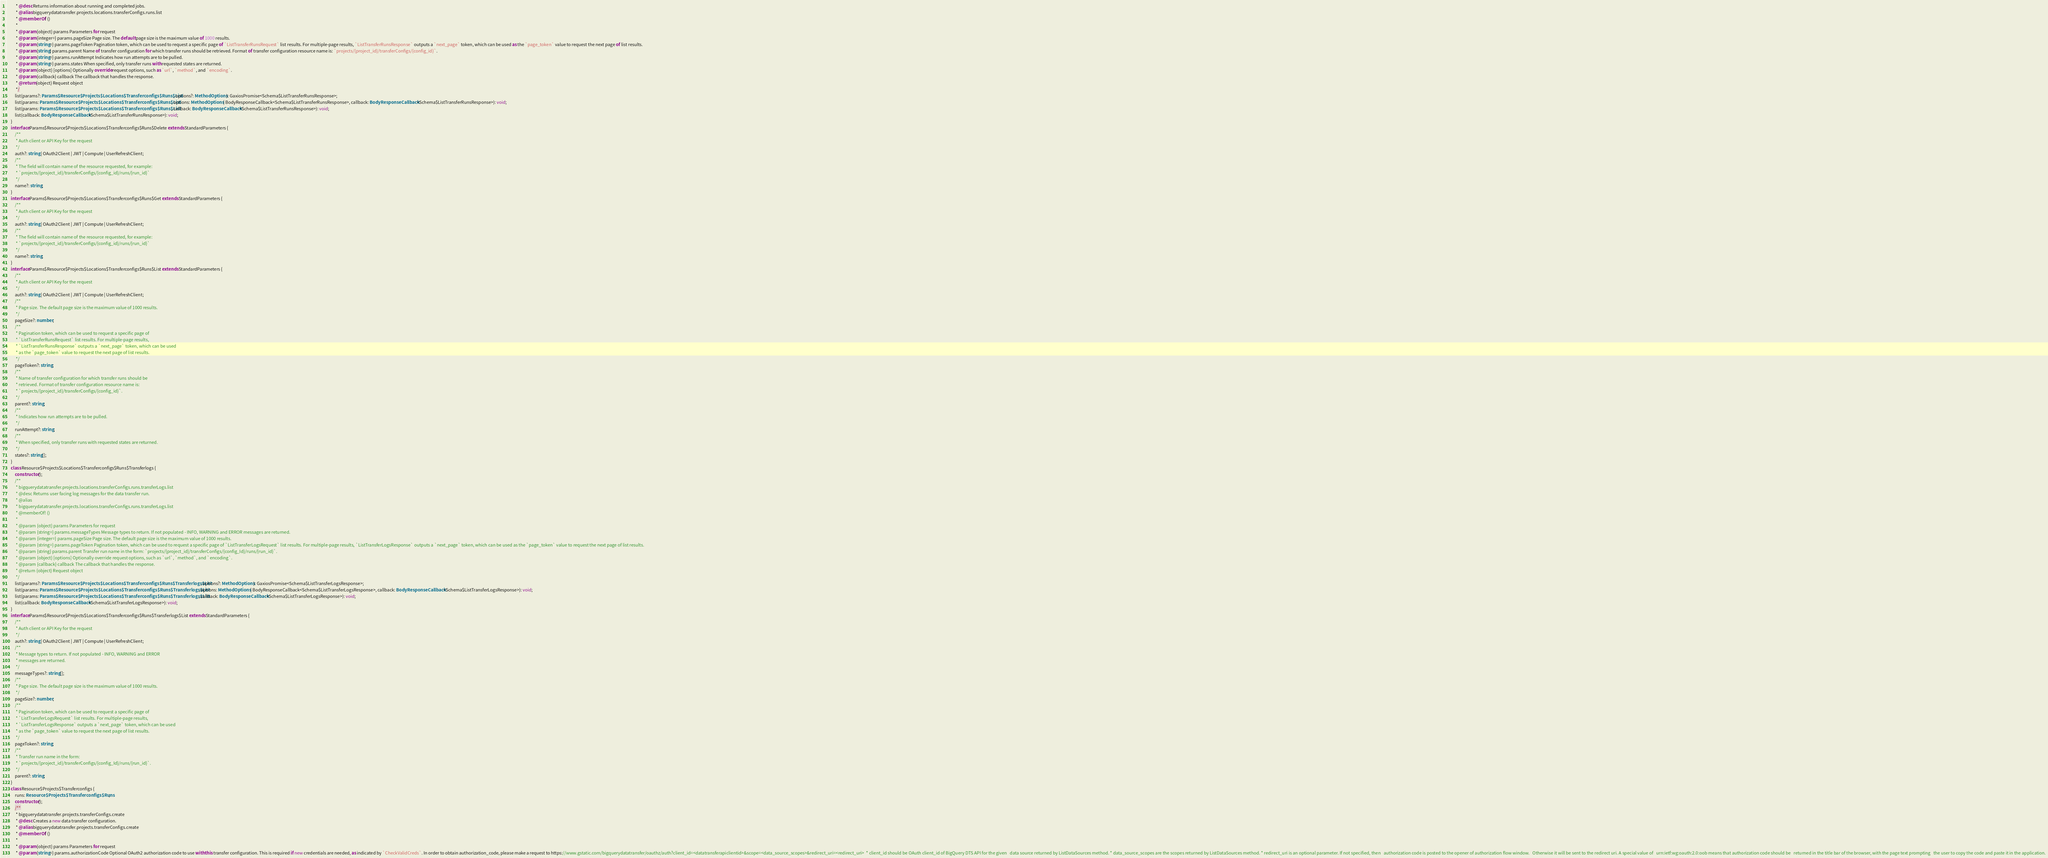Convert code to text. <code><loc_0><loc_0><loc_500><loc_500><_TypeScript_>         * @desc Returns information about running and completed jobs.
         * @alias bigquerydatatransfer.projects.locations.transferConfigs.runs.list
         * @memberOf! ()
         *
         * @param {object} params Parameters for request
         * @param {integer=} params.pageSize Page size. The default page size is the maximum value of 1000 results.
         * @param {string=} params.pageToken Pagination token, which can be used to request a specific page of `ListTransferRunsRequest` list results. For multiple-page results, `ListTransferRunsResponse` outputs a `next_page` token, which can be used as the `page_token` value to request the next page of list results.
         * @param {string} params.parent Name of transfer configuration for which transfer runs should be retrieved. Format of transfer configuration resource name is: `projects/{project_id}/transferConfigs/{config_id}`.
         * @param {string=} params.runAttempt Indicates how run attempts are to be pulled.
         * @param {string=} params.states When specified, only transfer runs with requested states are returned.
         * @param {object} [options] Optionally override request options, such as `url`, `method`, and `encoding`.
         * @param {callback} callback The callback that handles the response.
         * @return {object} Request object
         */
        list(params?: Params$Resource$Projects$Locations$Transferconfigs$Runs$List, options?: MethodOptions): GaxiosPromise<Schema$ListTransferRunsResponse>;
        list(params: Params$Resource$Projects$Locations$Transferconfigs$Runs$List, options: MethodOptions | BodyResponseCallback<Schema$ListTransferRunsResponse>, callback: BodyResponseCallback<Schema$ListTransferRunsResponse>): void;
        list(params: Params$Resource$Projects$Locations$Transferconfigs$Runs$List, callback: BodyResponseCallback<Schema$ListTransferRunsResponse>): void;
        list(callback: BodyResponseCallback<Schema$ListTransferRunsResponse>): void;
    }
    interface Params$Resource$Projects$Locations$Transferconfigs$Runs$Delete extends StandardParameters {
        /**
         * Auth client or API Key for the request
         */
        auth?: string | OAuth2Client | JWT | Compute | UserRefreshClient;
        /**
         * The field will contain name of the resource requested, for example:
         * `projects/{project_id}/transferConfigs/{config_id}/runs/{run_id}`
         */
        name?: string;
    }
    interface Params$Resource$Projects$Locations$Transferconfigs$Runs$Get extends StandardParameters {
        /**
         * Auth client or API Key for the request
         */
        auth?: string | OAuth2Client | JWT | Compute | UserRefreshClient;
        /**
         * The field will contain name of the resource requested, for example:
         * `projects/{project_id}/transferConfigs/{config_id}/runs/{run_id}`
         */
        name?: string;
    }
    interface Params$Resource$Projects$Locations$Transferconfigs$Runs$List extends StandardParameters {
        /**
         * Auth client or API Key for the request
         */
        auth?: string | OAuth2Client | JWT | Compute | UserRefreshClient;
        /**
         * Page size. The default page size is the maximum value of 1000 results.
         */
        pageSize?: number;
        /**
         * Pagination token, which can be used to request a specific page of
         * `ListTransferRunsRequest` list results. For multiple-page results,
         * `ListTransferRunsResponse` outputs a `next_page` token, which can be used
         * as the `page_token` value to request the next page of list results.
         */
        pageToken?: string;
        /**
         * Name of transfer configuration for which transfer runs should be
         * retrieved. Format of transfer configuration resource name is:
         * `projects/{project_id}/transferConfigs/{config_id}`.
         */
        parent?: string;
        /**
         * Indicates how run attempts are to be pulled.
         */
        runAttempt?: string;
        /**
         * When specified, only transfer runs with requested states are returned.
         */
        states?: string[];
    }
    class Resource$Projects$Locations$Transferconfigs$Runs$Transferlogs {
        constructor();
        /**
         * bigquerydatatransfer.projects.locations.transferConfigs.runs.transferLogs.list
         * @desc Returns user facing log messages for the data transfer run.
         * @alias
         * bigquerydatatransfer.projects.locations.transferConfigs.runs.transferLogs.list
         * @memberOf! ()
         *
         * @param {object} params Parameters for request
         * @param {string=} params.messageTypes Message types to return. If not populated - INFO, WARNING and ERROR messages are returned.
         * @param {integer=} params.pageSize Page size. The default page size is the maximum value of 1000 results.
         * @param {string=} params.pageToken Pagination token, which can be used to request a specific page of `ListTransferLogsRequest` list results. For multiple-page results, `ListTransferLogsResponse` outputs a `next_page` token, which can be used as the `page_token` value to request the next page of list results.
         * @param {string} params.parent Transfer run name in the form: `projects/{project_id}/transferConfigs/{config_Id}/runs/{run_id}`.
         * @param {object} [options] Optionally override request options, such as `url`, `method`, and `encoding`.
         * @param {callback} callback The callback that handles the response.
         * @return {object} Request object
         */
        list(params?: Params$Resource$Projects$Locations$Transferconfigs$Runs$Transferlogs$List, options?: MethodOptions): GaxiosPromise<Schema$ListTransferLogsResponse>;
        list(params: Params$Resource$Projects$Locations$Transferconfigs$Runs$Transferlogs$List, options: MethodOptions | BodyResponseCallback<Schema$ListTransferLogsResponse>, callback: BodyResponseCallback<Schema$ListTransferLogsResponse>): void;
        list(params: Params$Resource$Projects$Locations$Transferconfigs$Runs$Transferlogs$List, callback: BodyResponseCallback<Schema$ListTransferLogsResponse>): void;
        list(callback: BodyResponseCallback<Schema$ListTransferLogsResponse>): void;
    }
    interface Params$Resource$Projects$Locations$Transferconfigs$Runs$Transferlogs$List extends StandardParameters {
        /**
         * Auth client or API Key for the request
         */
        auth?: string | OAuth2Client | JWT | Compute | UserRefreshClient;
        /**
         * Message types to return. If not populated - INFO, WARNING and ERROR
         * messages are returned.
         */
        messageTypes?: string[];
        /**
         * Page size. The default page size is the maximum value of 1000 results.
         */
        pageSize?: number;
        /**
         * Pagination token, which can be used to request a specific page of
         * `ListTransferLogsRequest` list results. For multiple-page results,
         * `ListTransferLogsResponse` outputs a `next_page` token, which can be used
         * as the `page_token` value to request the next page of list results.
         */
        pageToken?: string;
        /**
         * Transfer run name in the form:
         * `projects/{project_id}/transferConfigs/{config_Id}/runs/{run_id}`.
         */
        parent?: string;
    }
    class Resource$Projects$Transferconfigs {
        runs: Resource$Projects$Transferconfigs$Runs;
        constructor();
        /**
         * bigquerydatatransfer.projects.transferConfigs.create
         * @desc Creates a new data transfer configuration.
         * @alias bigquerydatatransfer.projects.transferConfigs.create
         * @memberOf! ()
         *
         * @param {object} params Parameters for request
         * @param {string=} params.authorizationCode Optional OAuth2 authorization code to use with this transfer configuration. This is required if new credentials are needed, as indicated by `CheckValidCreds`. In order to obtain authorization_code, please make a request to https://www.gstatic.com/bigquerydatatransfer/oauthz/auth?client_id=<datatransferapiclientid>&scope=<data_source_scopes>&redirect_uri=<redirect_uri>  * client_id should be OAuth client_id of BigQuery DTS API for the given   data source returned by ListDataSources method. * data_source_scopes are the scopes returned by ListDataSources method. * redirect_uri is an optional parameter. If not specified, then   authorization code is posted to the opener of authorization flow window.   Otherwise it will be sent to the redirect uri. A special value of   urn:ietf:wg:oauth:2.0:oob means that authorization code should be   returned in the title bar of the browser, with the page text prompting   the user to copy the code and paste it in the application.</code> 